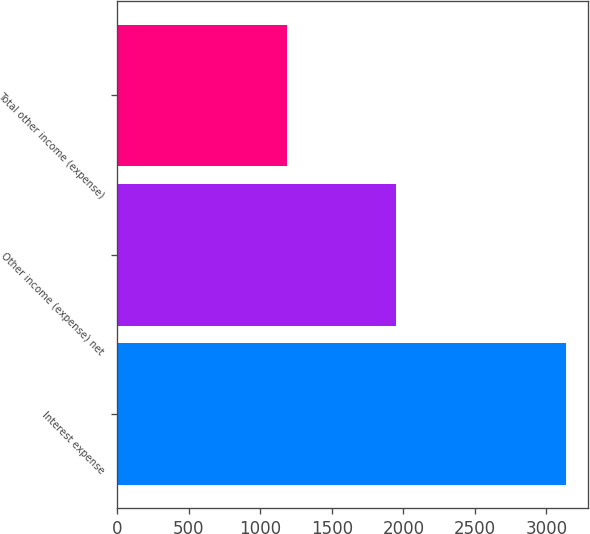Convert chart. <chart><loc_0><loc_0><loc_500><loc_500><bar_chart><fcel>Interest expense<fcel>Other income (expense) net<fcel>Total other income (expense)<nl><fcel>3136<fcel>1952<fcel>1184<nl></chart> 